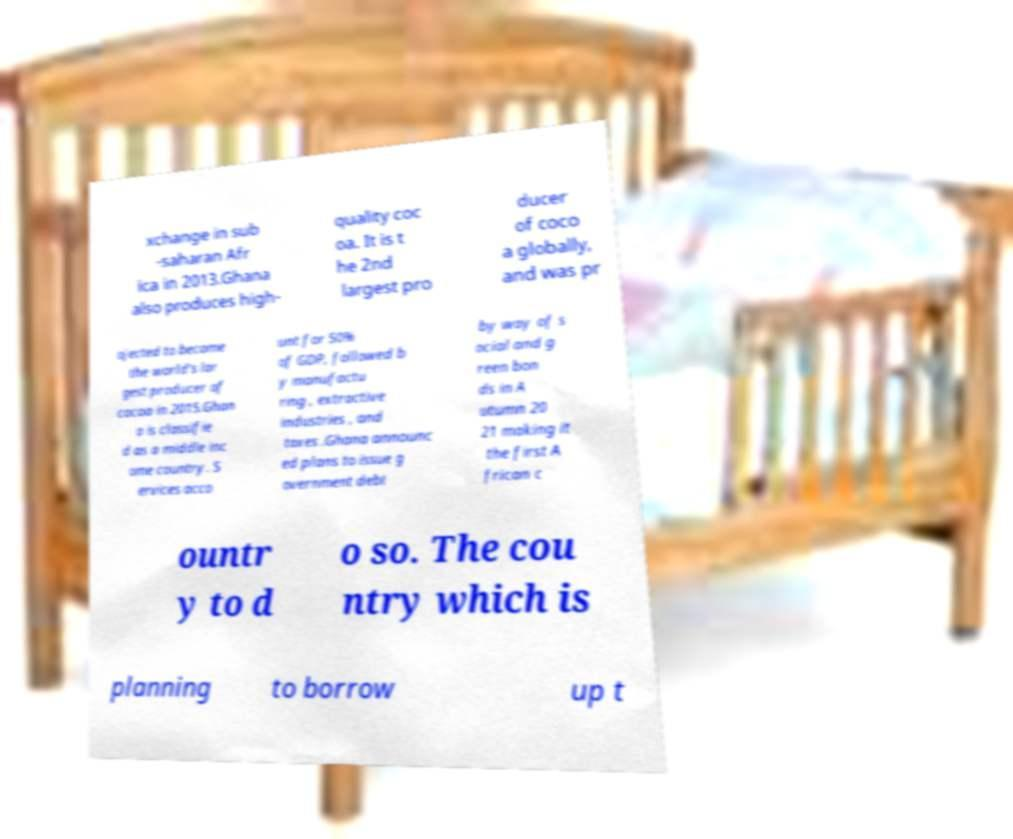Can you read and provide the text displayed in the image?This photo seems to have some interesting text. Can you extract and type it out for me? xchange in sub -saharan Afr ica in 2013.Ghana also produces high- quality coc oa. It is t he 2nd largest pro ducer of coco a globally, and was pr ojected to become the world's lar gest producer of cocoa in 2015.Ghan a is classifie d as a middle inc ome country. S ervices acco unt for 50% of GDP, followed b y manufactu ring , extractive industries , and taxes .Ghana announc ed plans to issue g overnment debt by way of s ocial and g reen bon ds in A utumn 20 21 making it the first A frican c ountr y to d o so. The cou ntry which is planning to borrow up t 